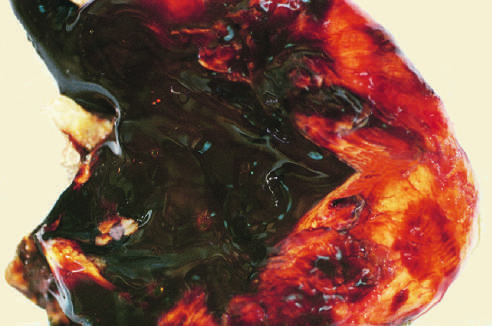does this abnormality show a large endometriotic cyst with degenerated blood (chocolate cyst)?
Answer the question using a single word or phrase. No 